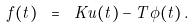Convert formula to latex. <formula><loc_0><loc_0><loc_500><loc_500>f ( t ) \ = \ K u ( t ) - T \phi ( t ) \, .</formula> 